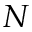<formula> <loc_0><loc_0><loc_500><loc_500>N</formula> 